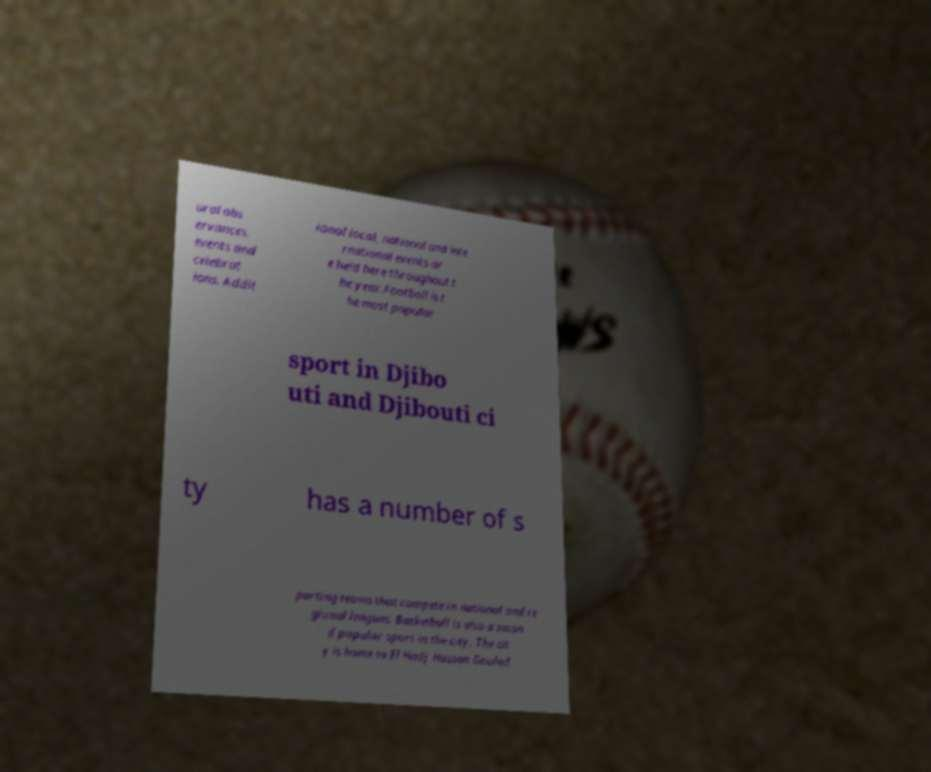Please read and relay the text visible in this image. What does it say? ural obs ervances, events and celebrat ions. Addit ional local, national and inte rnational events ar e held here throughout t he year.Football is t he most popular sport in Djibo uti and Djibouti ci ty has a number of s porting teams that compete in national and re gional leagues. Basketball is also a secon d popular sport in the city. The cit y is home to El Hadj Hassan Gouled 